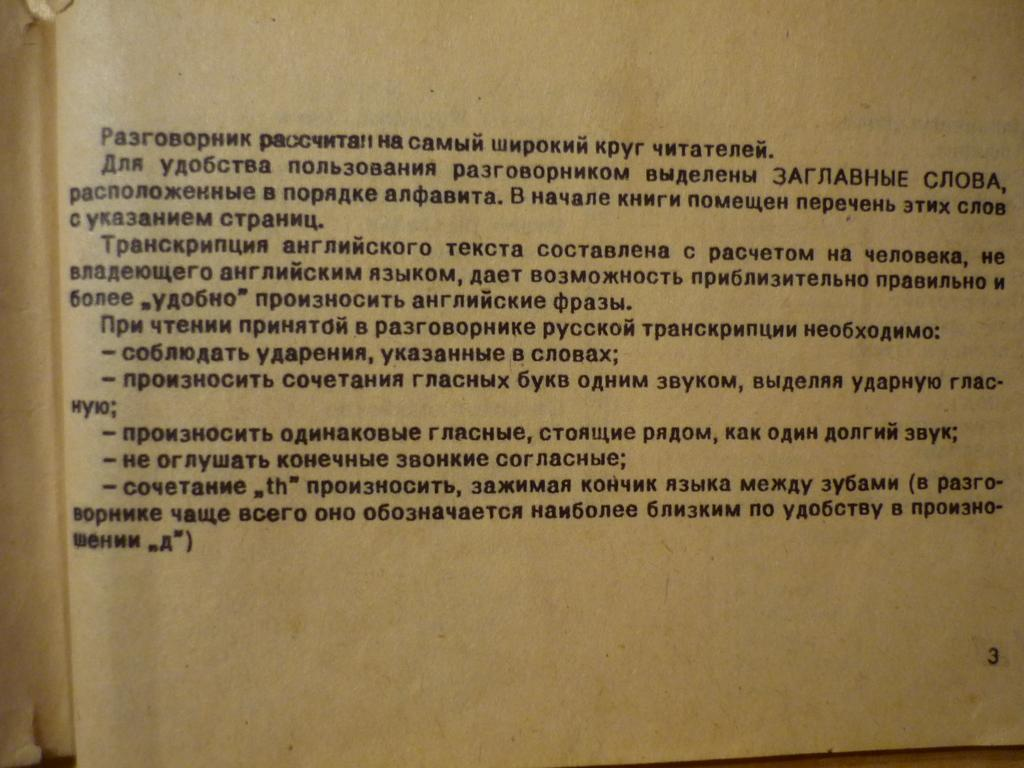<image>
Write a terse but informative summary of the picture. A discolored page filled with Russian writing is seen on page number 3. 